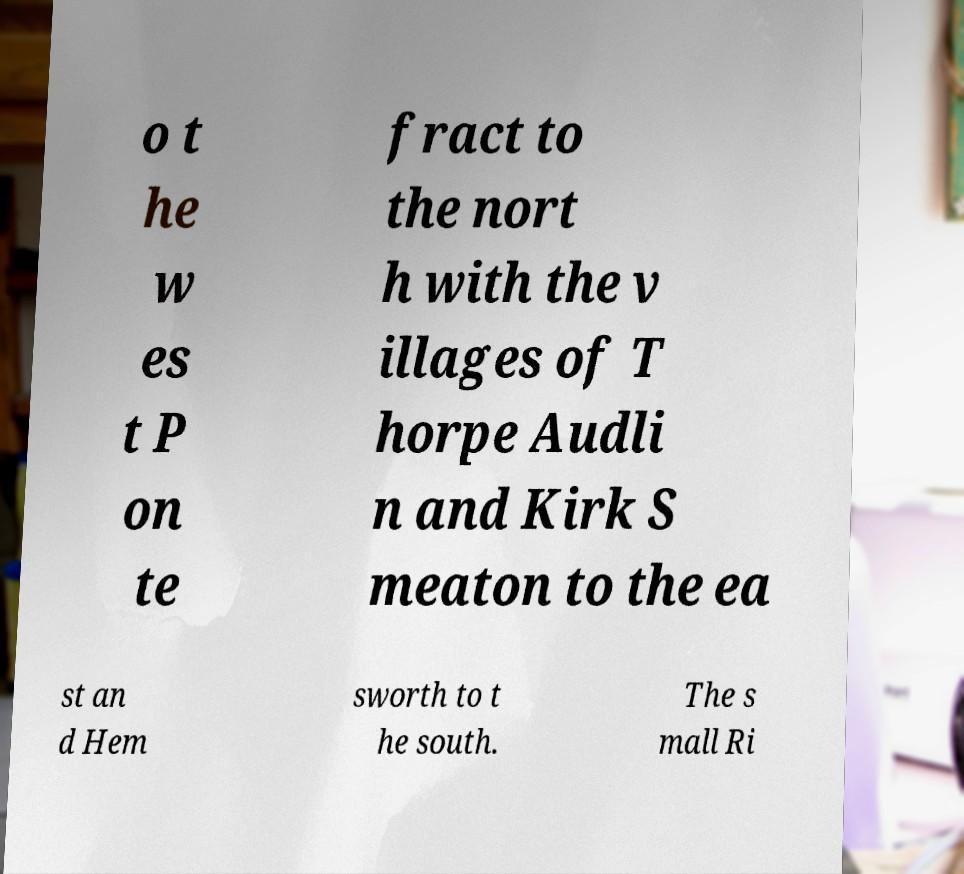Can you read and provide the text displayed in the image?This photo seems to have some interesting text. Can you extract and type it out for me? o t he w es t P on te fract to the nort h with the v illages of T horpe Audli n and Kirk S meaton to the ea st an d Hem sworth to t he south. The s mall Ri 